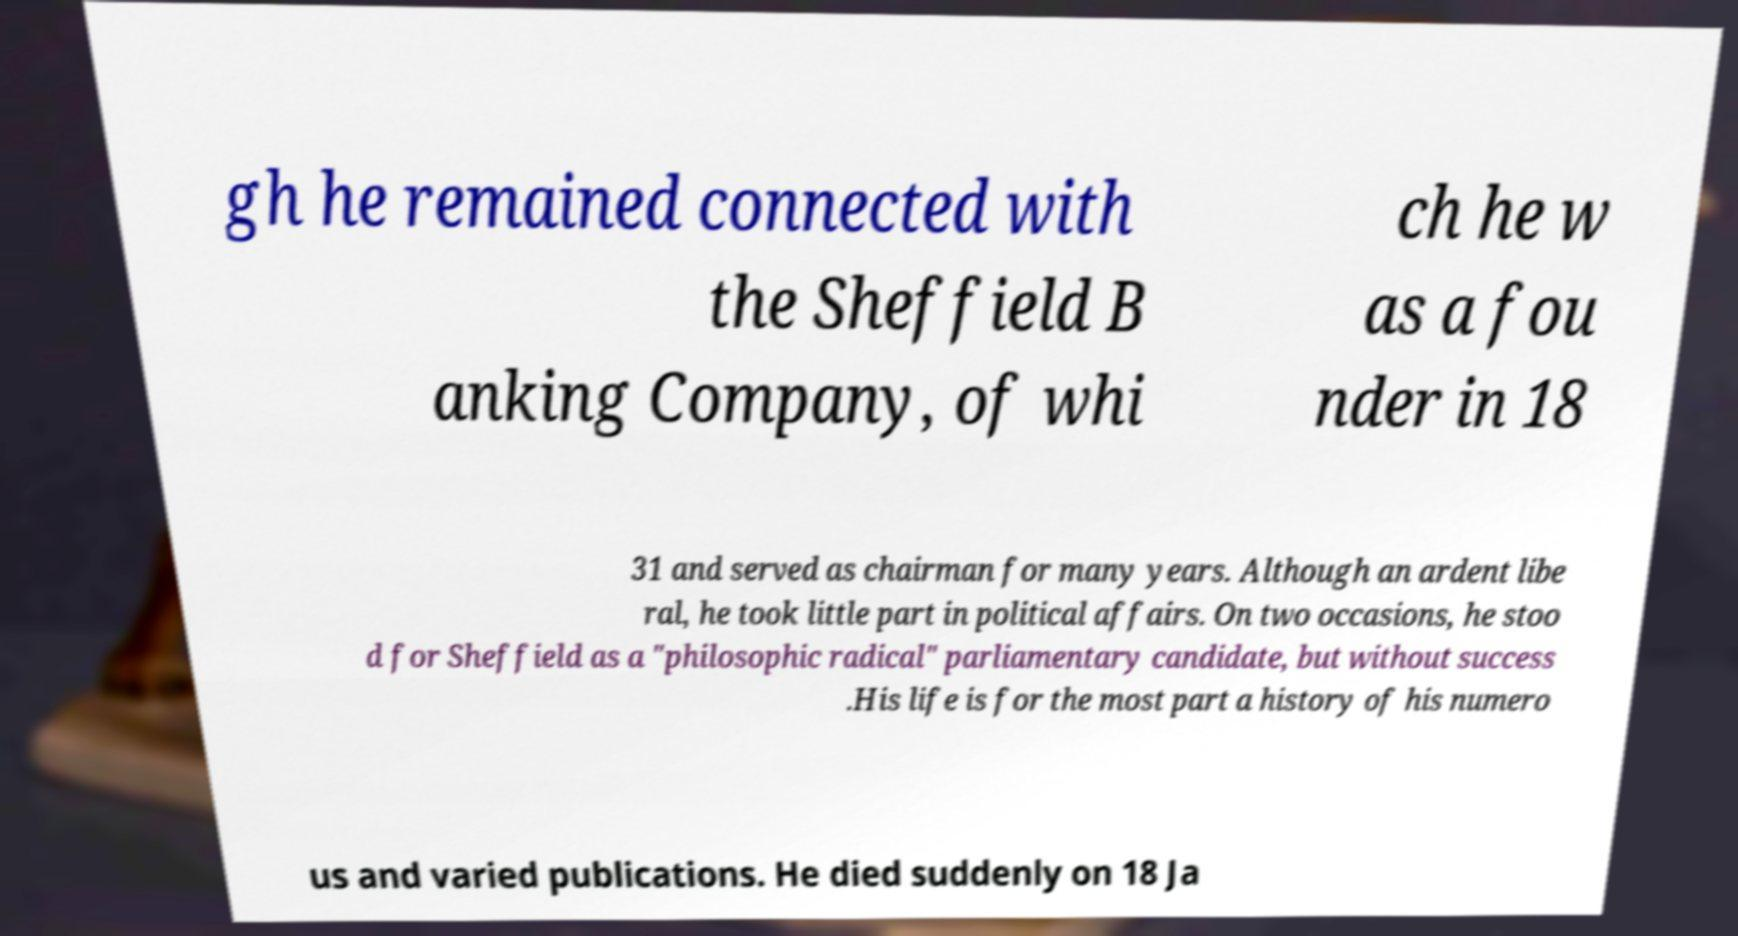What messages or text are displayed in this image? I need them in a readable, typed format. gh he remained connected with the Sheffield B anking Company, of whi ch he w as a fou nder in 18 31 and served as chairman for many years. Although an ardent libe ral, he took little part in political affairs. On two occasions, he stoo d for Sheffield as a "philosophic radical" parliamentary candidate, but without success .His life is for the most part a history of his numero us and varied publications. He died suddenly on 18 Ja 